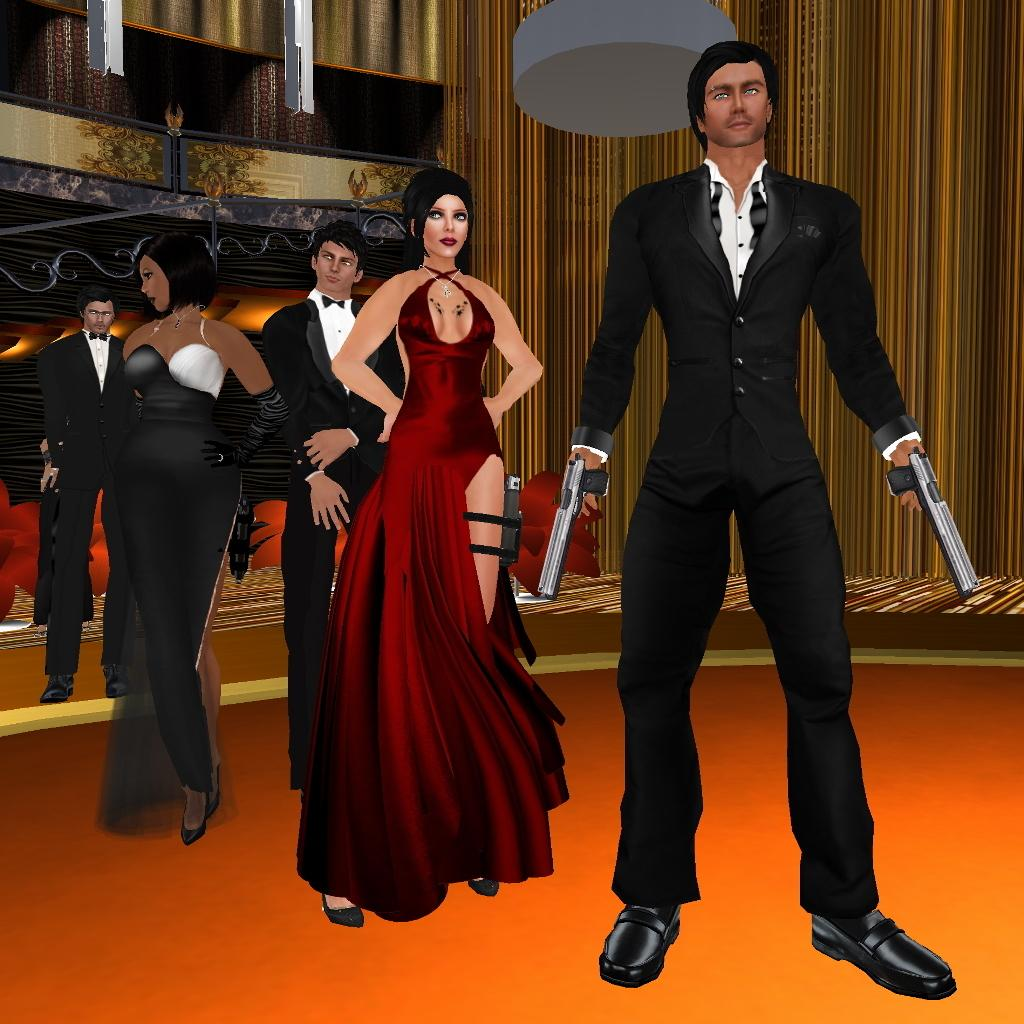What is happening in the middle of the image? There are persons standing in the middle of the image. What can be seen in the background of the image? There is a wall in the background of the image. What type of picture is this? The image is an animated picture. What type of dress is the army wearing in the image? There is no army or dress present in the image; it features persons standing in the middle of an animated picture with a wall in the background. 